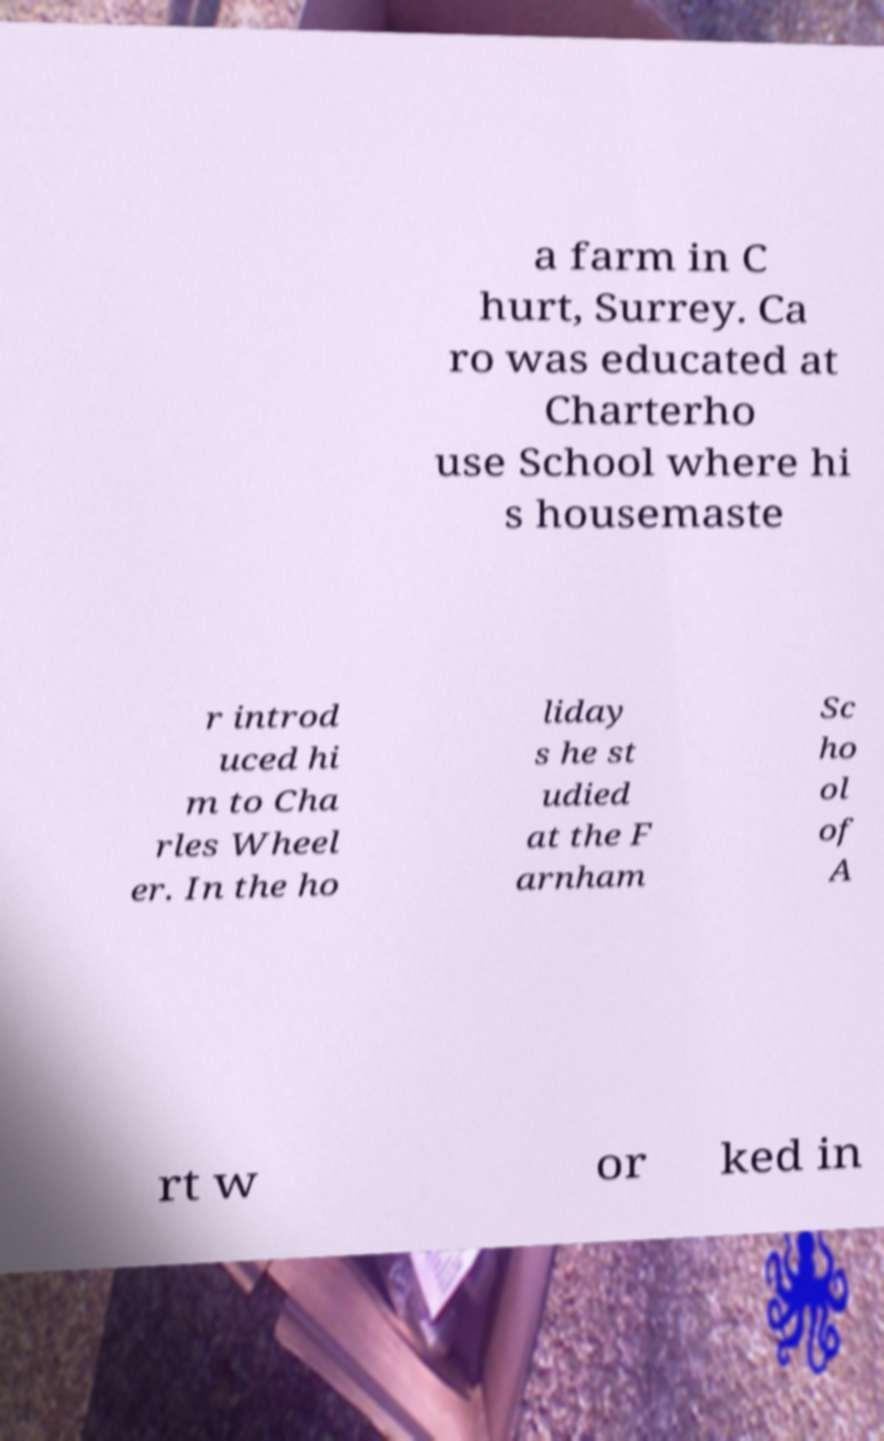There's text embedded in this image that I need extracted. Can you transcribe it verbatim? a farm in C hurt, Surrey. Ca ro was educated at Charterho use School where hi s housemaste r introd uced hi m to Cha rles Wheel er. In the ho liday s he st udied at the F arnham Sc ho ol of A rt w or ked in 